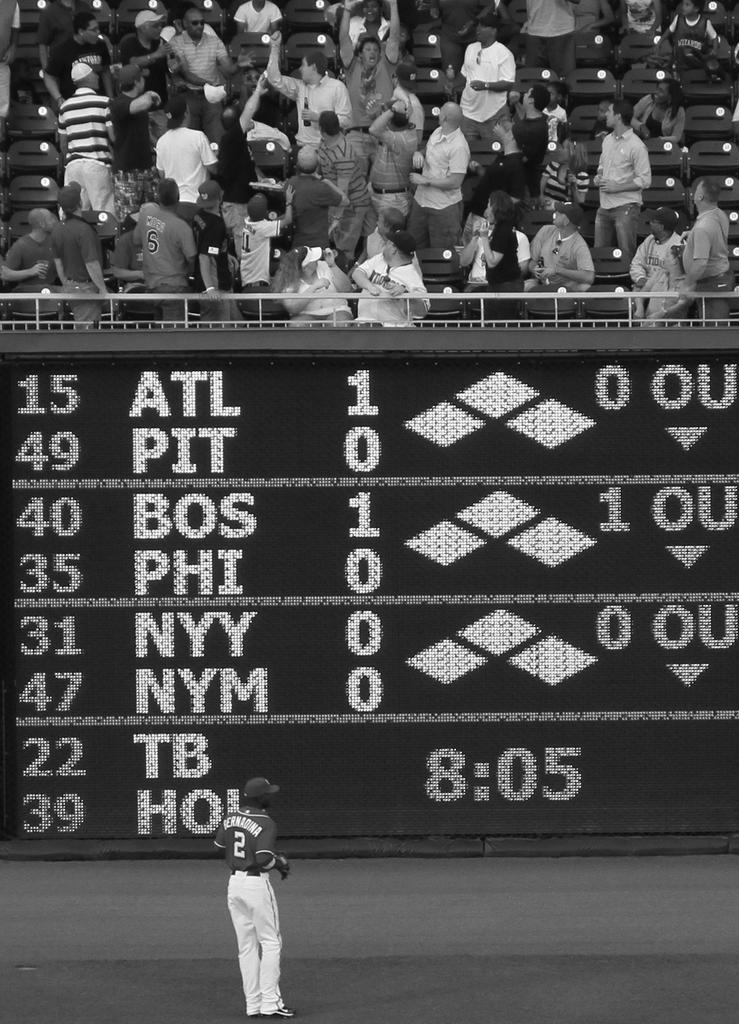How many "ou" are in the bos phi section?
Your answer should be very brief. 1. What time is shown?
Give a very brief answer. 8:05. 